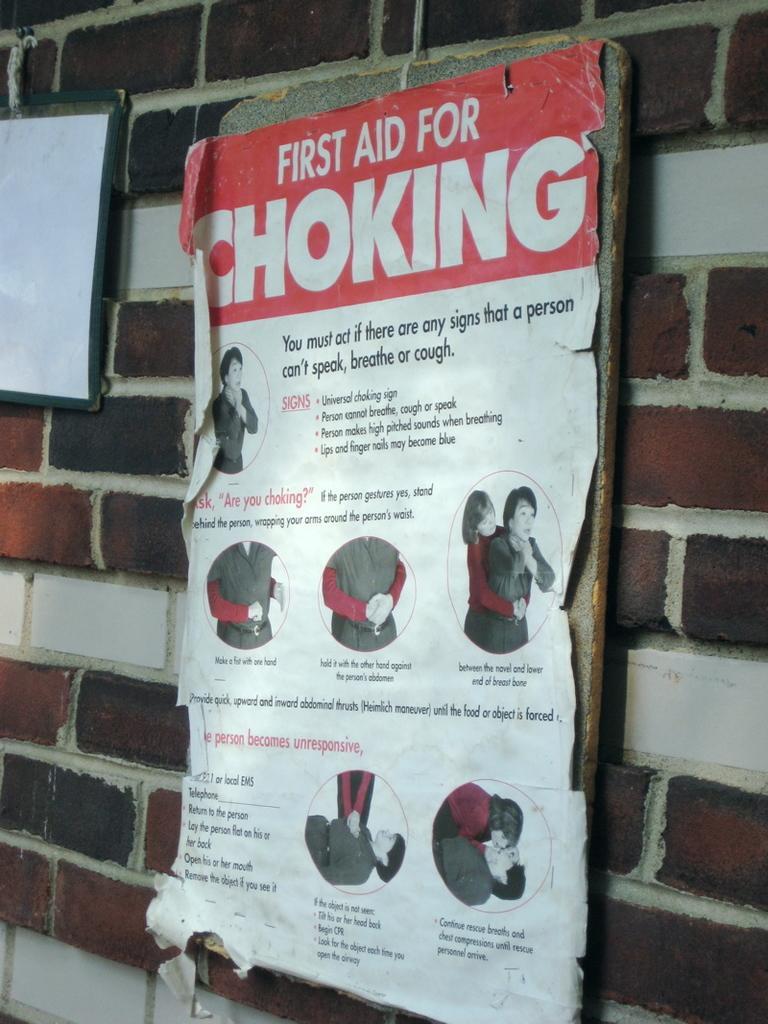Could you give a brief overview of what you see in this image? In this picture we can see a wall on the right side, there are two boards on the wall, we can see some text and depictions of persons on the wall. 